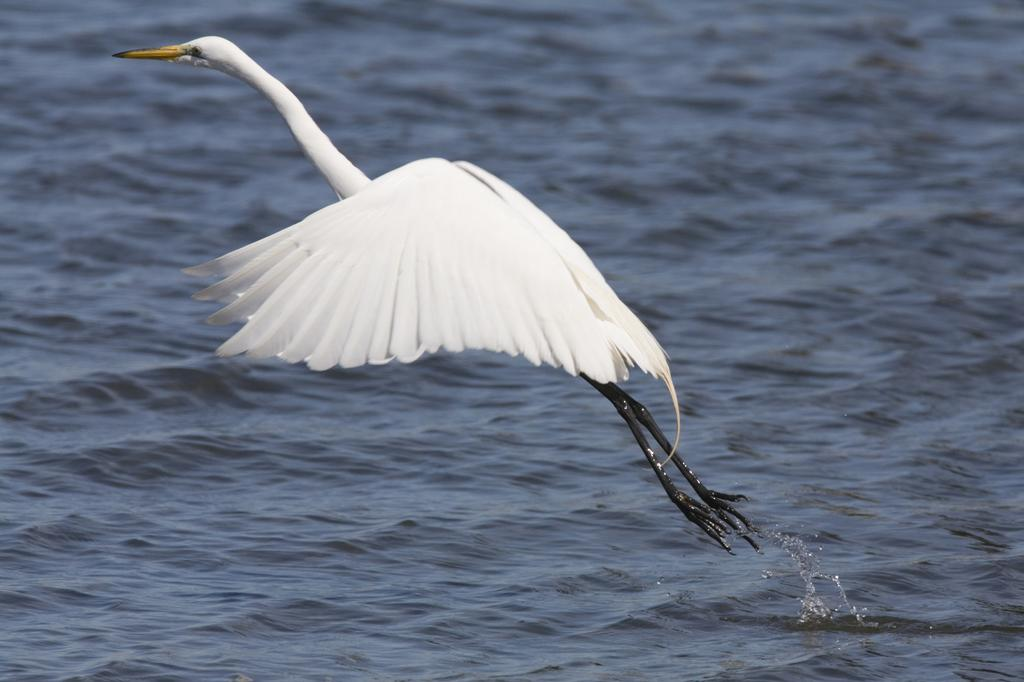What type of animal can be seen in the image? There is a white bird in the image. What is the bird doing in the image? The bird is flying in the image. Where is the bird located in relation to the water? The bird is above the water in the image. What type of news can be heard coming from the bird in the image? There is no indication in the image that the bird is making any news or sounds, as birds typically do not produce news. 